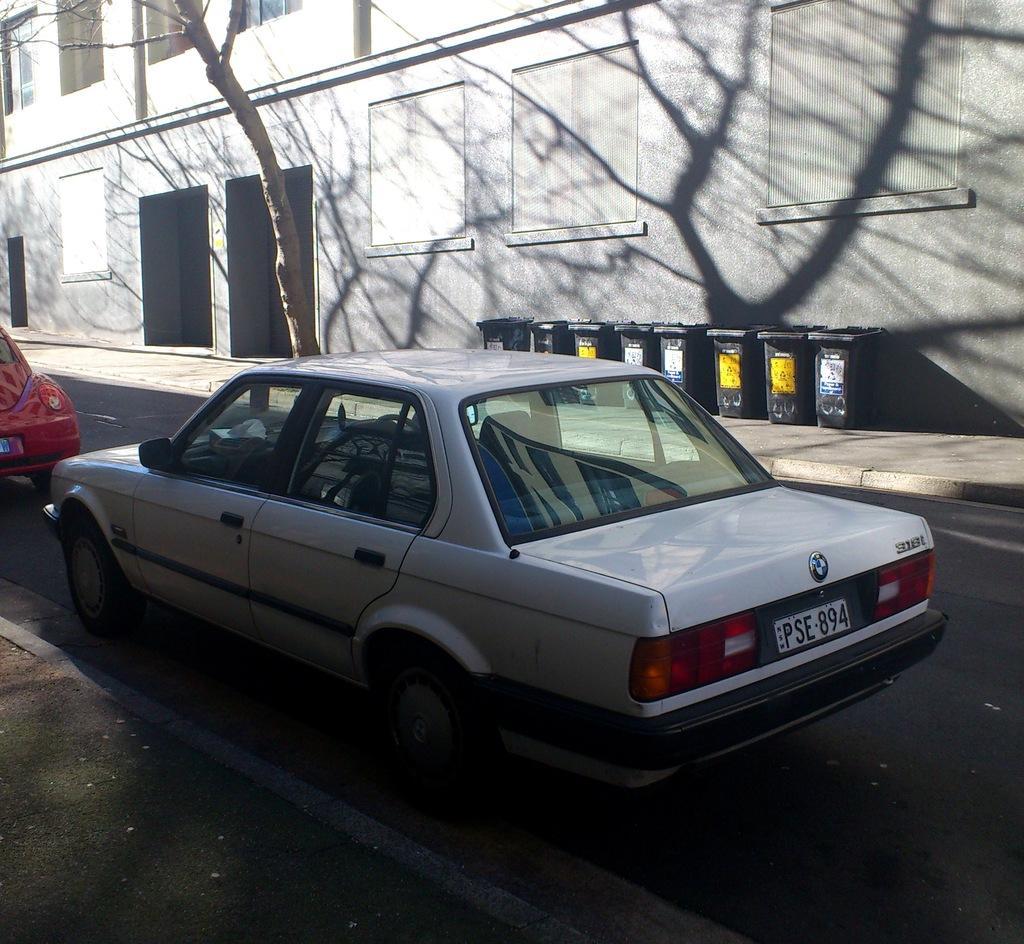In one or two sentences, can you explain what this image depicts? In the image we can see there are two vehicles on the road. This is a road, garbage bin, building and a tree. These are the lights and this is a number plate of the vehicle. 